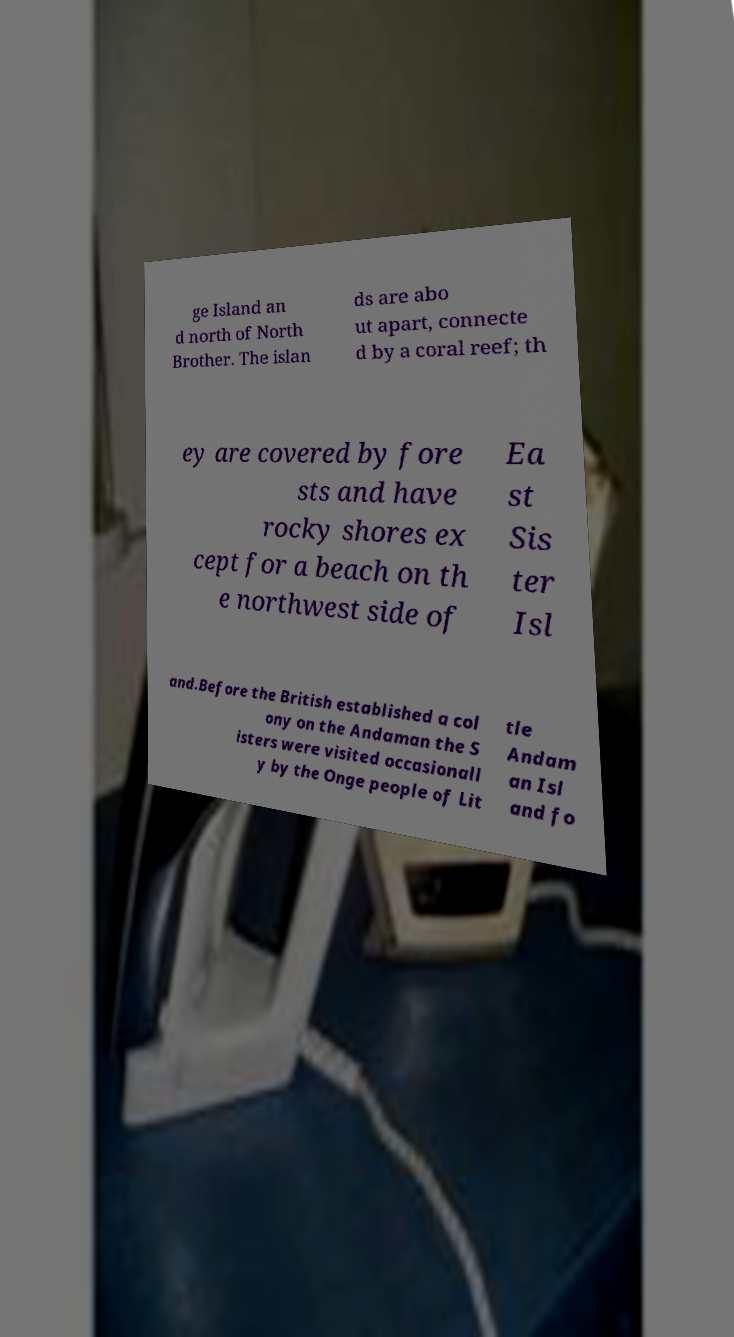Could you extract and type out the text from this image? ge Island an d north of North Brother. The islan ds are abo ut apart, connecte d by a coral reef; th ey are covered by fore sts and have rocky shores ex cept for a beach on th e northwest side of Ea st Sis ter Isl and.Before the British established a col ony on the Andaman the S isters were visited occasionall y by the Onge people of Lit tle Andam an Isl and fo 